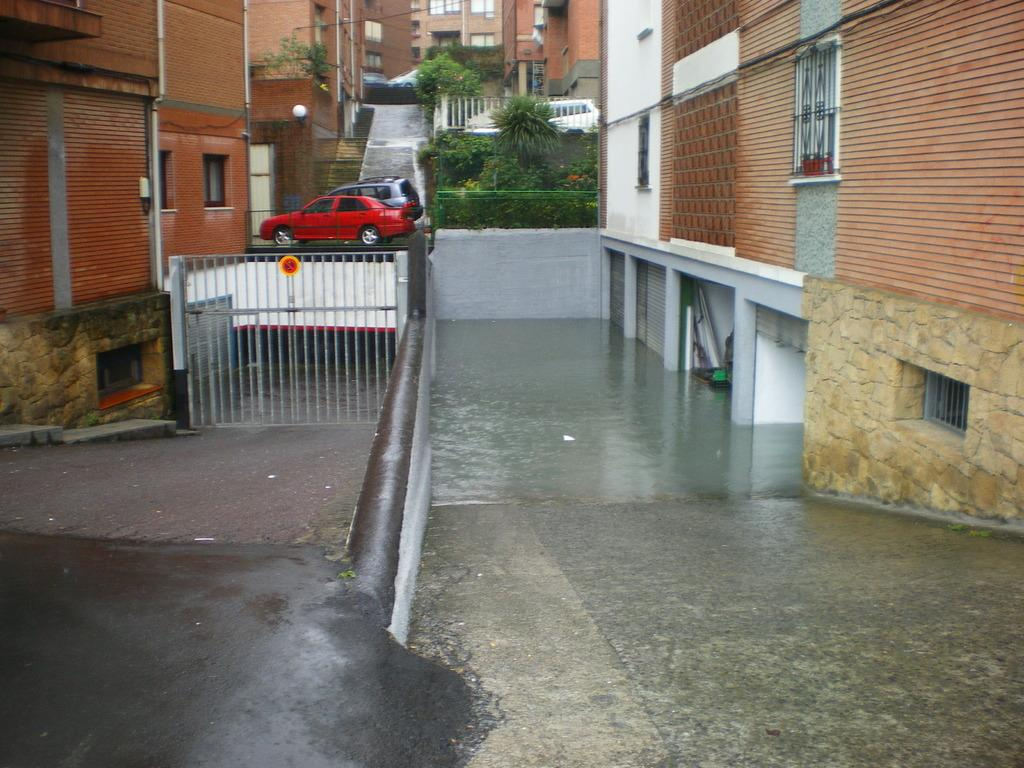What is the main structure visible in the image? There is a gate in the image. What else can be seen in the image besides the gate? There are buildings, vehicles, plants, pipes on the walls, water stored on the floor, objects, windows, and shutters visible in the image. What type of board is being used to solve mathematical problems in the image? There is no board or mathematical problems present in the image. What angle is the camera positioned at in the image? The angle of the camera is not mentioned in the provided facts, so it cannot be determined from the image. 